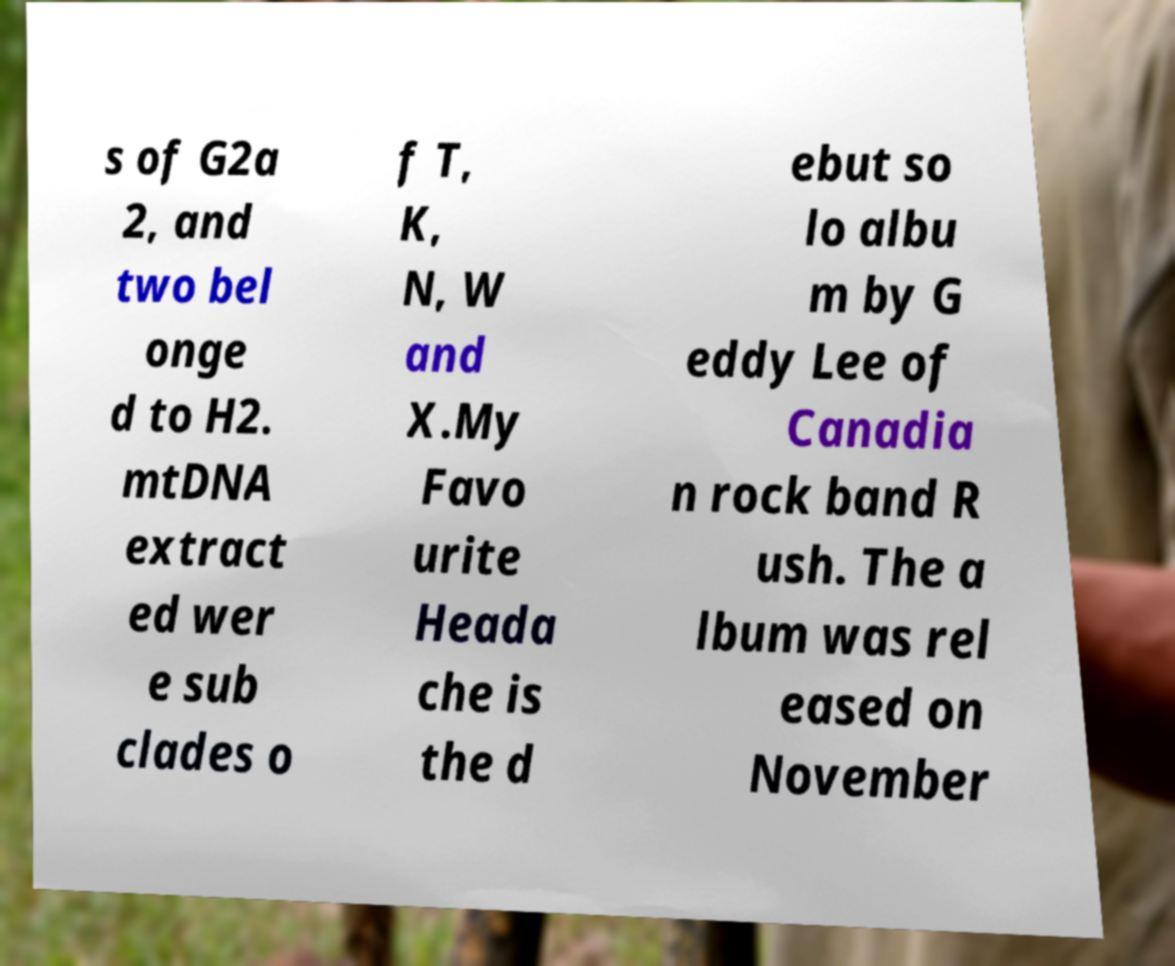Can you read and provide the text displayed in the image?This photo seems to have some interesting text. Can you extract and type it out for me? s of G2a 2, and two bel onge d to H2. mtDNA extract ed wer e sub clades o f T, K, N, W and X.My Favo urite Heada che is the d ebut so lo albu m by G eddy Lee of Canadia n rock band R ush. The a lbum was rel eased on November 